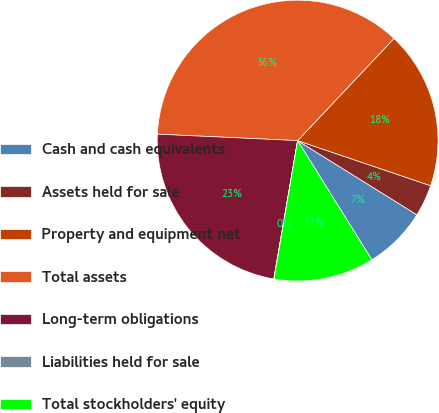Convert chart. <chart><loc_0><loc_0><loc_500><loc_500><pie_chart><fcel>Cash and cash equivalents<fcel>Assets held for sale<fcel>Property and equipment net<fcel>Total assets<fcel>Long-term obligations<fcel>Liabilities held for sale<fcel>Total stockholders' equity<nl><fcel>7.28%<fcel>3.65%<fcel>18.17%<fcel>36.31%<fcel>23.02%<fcel>0.02%<fcel>11.56%<nl></chart> 